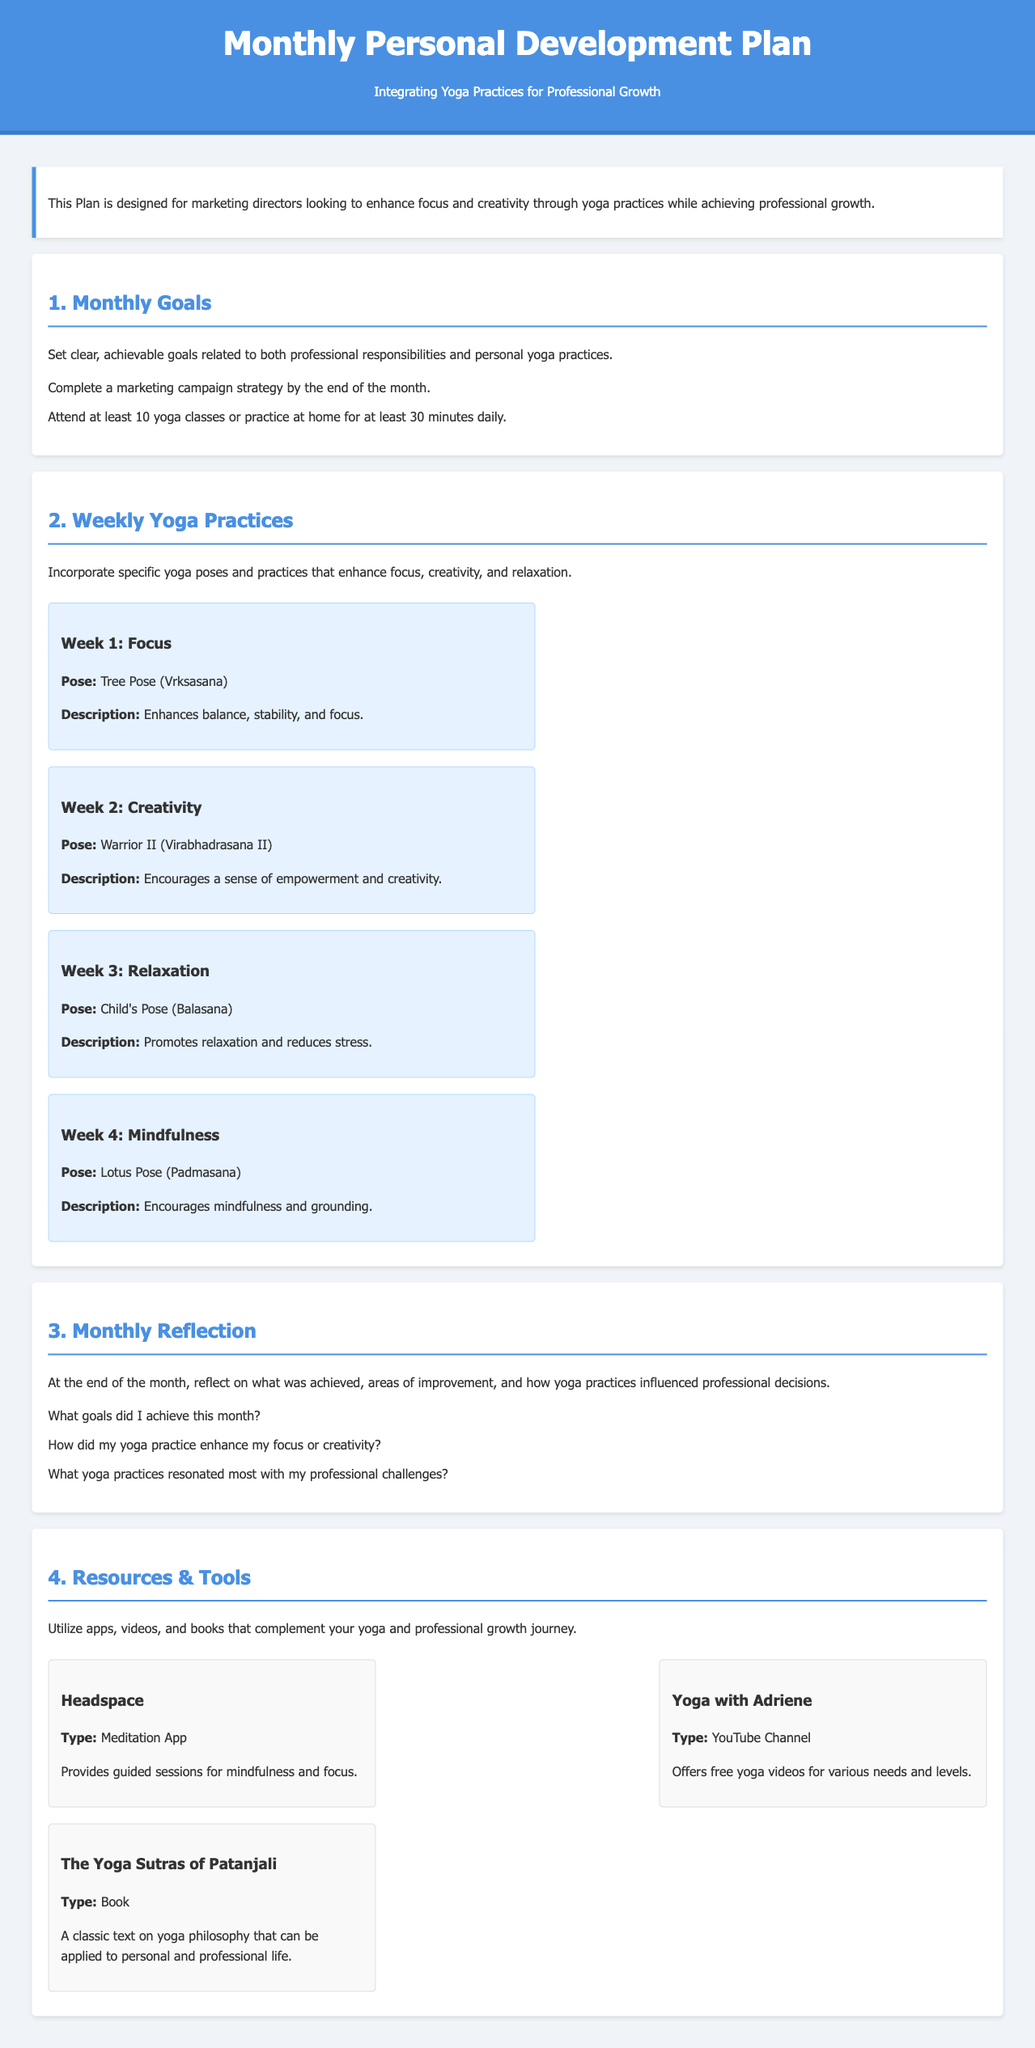What are the overall goals of the Monthly Personal Development Plan? The Monthly Personal Development Plan aims to enhance focus and creativity through yoga practices while achieving professional growth.
Answer: Enhance focus and creativity How many yoga classes should be attended at a minimum? The document states that attending at least 10 yoga classes or practicing at home for at least 30 minutes daily is a goal.
Answer: 10 yoga classes What yoga pose is recommended for Week 2? Week 2 focuses on creativity with the Warrior II pose.
Answer: Warrior II What is the focus of the Week 3 yoga practice? Week 3 emphasizes relaxation through specific yoga practices.
Answer: Relaxation What is one tool mentioned in the Resources section? The document lists several resources, one of which is Headspace, a meditation app.
Answer: Headspace How many questions are included in the Monthly Reflection section? The Monthly Reflection section includes three specific questions for self-evaluation.
Answer: Three questions Which pose is associated with mindfulness in Week 4? Lotus Pose is designated for mindfulness in the Monthly Personal Development Plan.
Answer: Lotus Pose What kind of content can be found on the Yoga with Adriene channel? Yoga with Adriene offers free yoga videos for various needs and levels.
Answer: Free yoga videos What should be reflected on at the end of the month? The Monthly Reflection requires consideration of achieved goals and the impact of yoga practices.
Answer: Achieved goals and yoga impacts 